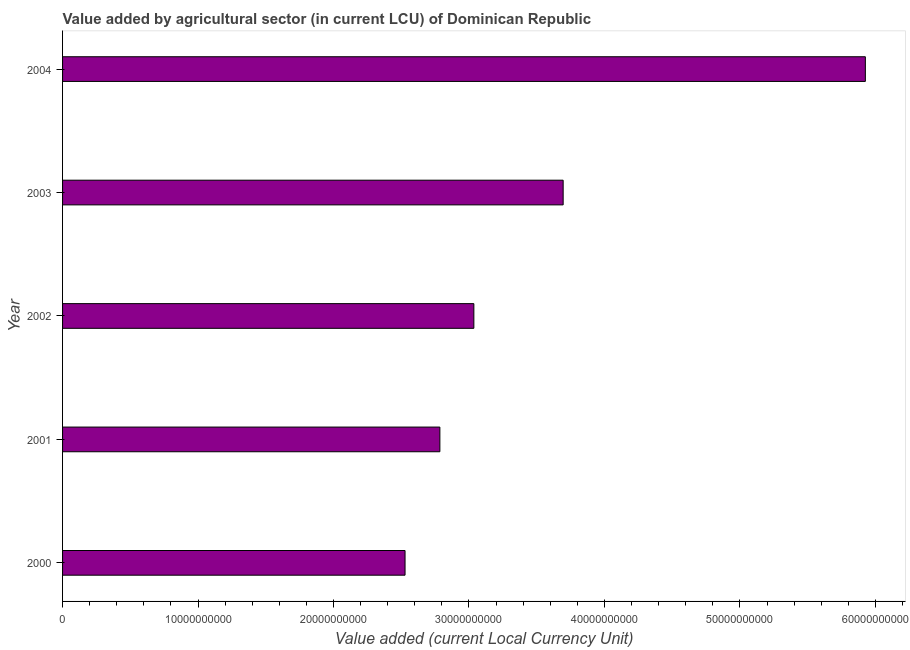Does the graph contain any zero values?
Offer a terse response. No. Does the graph contain grids?
Keep it short and to the point. No. What is the title of the graph?
Your answer should be compact. Value added by agricultural sector (in current LCU) of Dominican Republic. What is the label or title of the X-axis?
Ensure brevity in your answer.  Value added (current Local Currency Unit). What is the value added by agriculture sector in 2003?
Make the answer very short. 3.70e+1. Across all years, what is the maximum value added by agriculture sector?
Make the answer very short. 5.93e+1. Across all years, what is the minimum value added by agriculture sector?
Offer a very short reply. 2.53e+1. In which year was the value added by agriculture sector maximum?
Your response must be concise. 2004. What is the sum of the value added by agriculture sector?
Give a very brief answer. 1.80e+11. What is the difference between the value added by agriculture sector in 2000 and 2001?
Give a very brief answer. -2.57e+09. What is the average value added by agriculture sector per year?
Offer a very short reply. 3.59e+1. What is the median value added by agriculture sector?
Make the answer very short. 3.04e+1. Do a majority of the years between 2002 and 2000 (inclusive) have value added by agriculture sector greater than 60000000000 LCU?
Provide a short and direct response. Yes. What is the ratio of the value added by agriculture sector in 2001 to that in 2003?
Give a very brief answer. 0.75. What is the difference between the highest and the second highest value added by agriculture sector?
Make the answer very short. 2.23e+1. What is the difference between the highest and the lowest value added by agriculture sector?
Your answer should be compact. 3.40e+1. Are all the bars in the graph horizontal?
Make the answer very short. Yes. What is the difference between two consecutive major ticks on the X-axis?
Make the answer very short. 1.00e+1. What is the Value added (current Local Currency Unit) in 2000?
Keep it short and to the point. 2.53e+1. What is the Value added (current Local Currency Unit) in 2001?
Provide a short and direct response. 2.79e+1. What is the Value added (current Local Currency Unit) of 2002?
Your answer should be very brief. 3.04e+1. What is the Value added (current Local Currency Unit) of 2003?
Provide a short and direct response. 3.70e+1. What is the Value added (current Local Currency Unit) of 2004?
Your answer should be very brief. 5.93e+1. What is the difference between the Value added (current Local Currency Unit) in 2000 and 2001?
Offer a very short reply. -2.57e+09. What is the difference between the Value added (current Local Currency Unit) in 2000 and 2002?
Offer a very short reply. -5.08e+09. What is the difference between the Value added (current Local Currency Unit) in 2000 and 2003?
Your response must be concise. -1.17e+1. What is the difference between the Value added (current Local Currency Unit) in 2000 and 2004?
Give a very brief answer. -3.40e+1. What is the difference between the Value added (current Local Currency Unit) in 2001 and 2002?
Your answer should be very brief. -2.51e+09. What is the difference between the Value added (current Local Currency Unit) in 2001 and 2003?
Provide a short and direct response. -9.10e+09. What is the difference between the Value added (current Local Currency Unit) in 2001 and 2004?
Provide a short and direct response. -3.14e+1. What is the difference between the Value added (current Local Currency Unit) in 2002 and 2003?
Your answer should be compact. -6.59e+09. What is the difference between the Value added (current Local Currency Unit) in 2002 and 2004?
Your answer should be compact. -2.89e+1. What is the difference between the Value added (current Local Currency Unit) in 2003 and 2004?
Provide a succinct answer. -2.23e+1. What is the ratio of the Value added (current Local Currency Unit) in 2000 to that in 2001?
Ensure brevity in your answer.  0.91. What is the ratio of the Value added (current Local Currency Unit) in 2000 to that in 2002?
Your answer should be very brief. 0.83. What is the ratio of the Value added (current Local Currency Unit) in 2000 to that in 2003?
Provide a short and direct response. 0.68. What is the ratio of the Value added (current Local Currency Unit) in 2000 to that in 2004?
Offer a very short reply. 0.43. What is the ratio of the Value added (current Local Currency Unit) in 2001 to that in 2002?
Provide a short and direct response. 0.92. What is the ratio of the Value added (current Local Currency Unit) in 2001 to that in 2003?
Offer a very short reply. 0.75. What is the ratio of the Value added (current Local Currency Unit) in 2001 to that in 2004?
Your answer should be very brief. 0.47. What is the ratio of the Value added (current Local Currency Unit) in 2002 to that in 2003?
Ensure brevity in your answer.  0.82. What is the ratio of the Value added (current Local Currency Unit) in 2002 to that in 2004?
Provide a succinct answer. 0.51. What is the ratio of the Value added (current Local Currency Unit) in 2003 to that in 2004?
Your response must be concise. 0.62. 